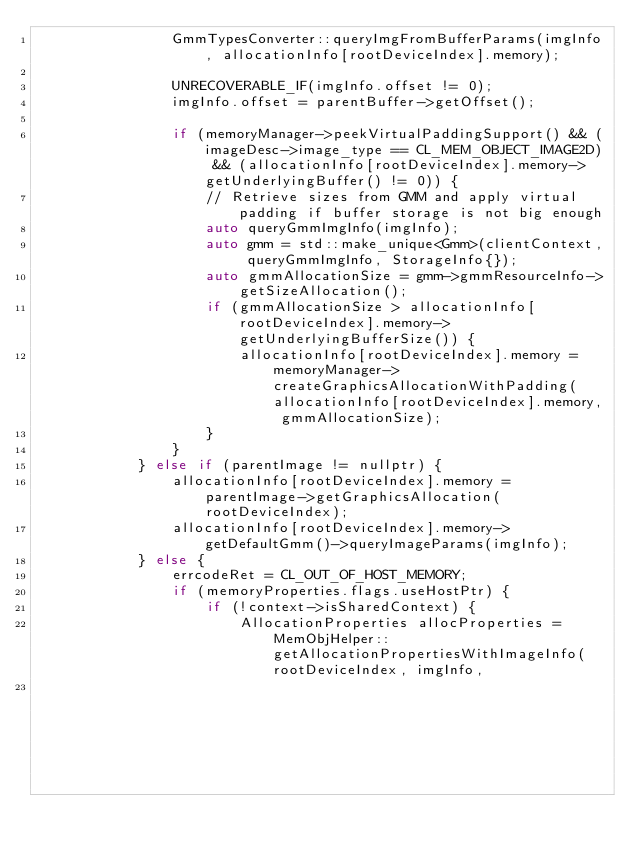Convert code to text. <code><loc_0><loc_0><loc_500><loc_500><_C++_>                GmmTypesConverter::queryImgFromBufferParams(imgInfo, allocationInfo[rootDeviceIndex].memory);

                UNRECOVERABLE_IF(imgInfo.offset != 0);
                imgInfo.offset = parentBuffer->getOffset();

                if (memoryManager->peekVirtualPaddingSupport() && (imageDesc->image_type == CL_MEM_OBJECT_IMAGE2D) && (allocationInfo[rootDeviceIndex].memory->getUnderlyingBuffer() != 0)) {
                    // Retrieve sizes from GMM and apply virtual padding if buffer storage is not big enough
                    auto queryGmmImgInfo(imgInfo);
                    auto gmm = std::make_unique<Gmm>(clientContext, queryGmmImgInfo, StorageInfo{});
                    auto gmmAllocationSize = gmm->gmmResourceInfo->getSizeAllocation();
                    if (gmmAllocationSize > allocationInfo[rootDeviceIndex].memory->getUnderlyingBufferSize()) {
                        allocationInfo[rootDeviceIndex].memory = memoryManager->createGraphicsAllocationWithPadding(allocationInfo[rootDeviceIndex].memory, gmmAllocationSize);
                    }
                }
            } else if (parentImage != nullptr) {
                allocationInfo[rootDeviceIndex].memory = parentImage->getGraphicsAllocation(rootDeviceIndex);
                allocationInfo[rootDeviceIndex].memory->getDefaultGmm()->queryImageParams(imgInfo);
            } else {
                errcodeRet = CL_OUT_OF_HOST_MEMORY;
                if (memoryProperties.flags.useHostPtr) {
                    if (!context->isSharedContext) {
                        AllocationProperties allocProperties = MemObjHelper::getAllocationPropertiesWithImageInfo(rootDeviceIndex, imgInfo,
                                                                                                                  false, // allocateMemory</code> 